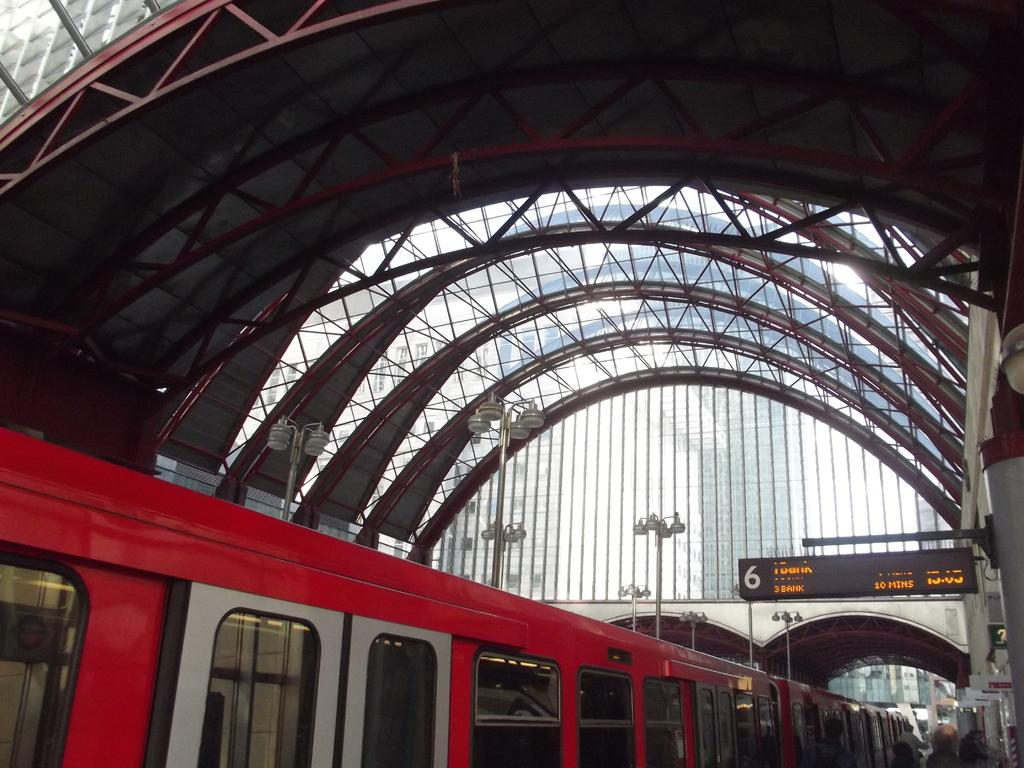What type of structures can be seen in the image? There are rods, light poles, and a digital board in the image. What type of material is used for the windows in the image? There are glass windows in the image. What mode of transportation is present in the image? There is a train in the image. Are there any people visible in the image? Yes, there are people in the image. What type of signage is present in the image? There are boards in the image. What general category of objects can be seen in the image? There are objects in the image. What type of scent can be detected in the image? There is no mention of any scent in the image, so it cannot be determined from the image. Is there a gate visible in the image? There is no mention of a gate in the image, so it cannot be determined from the image. 